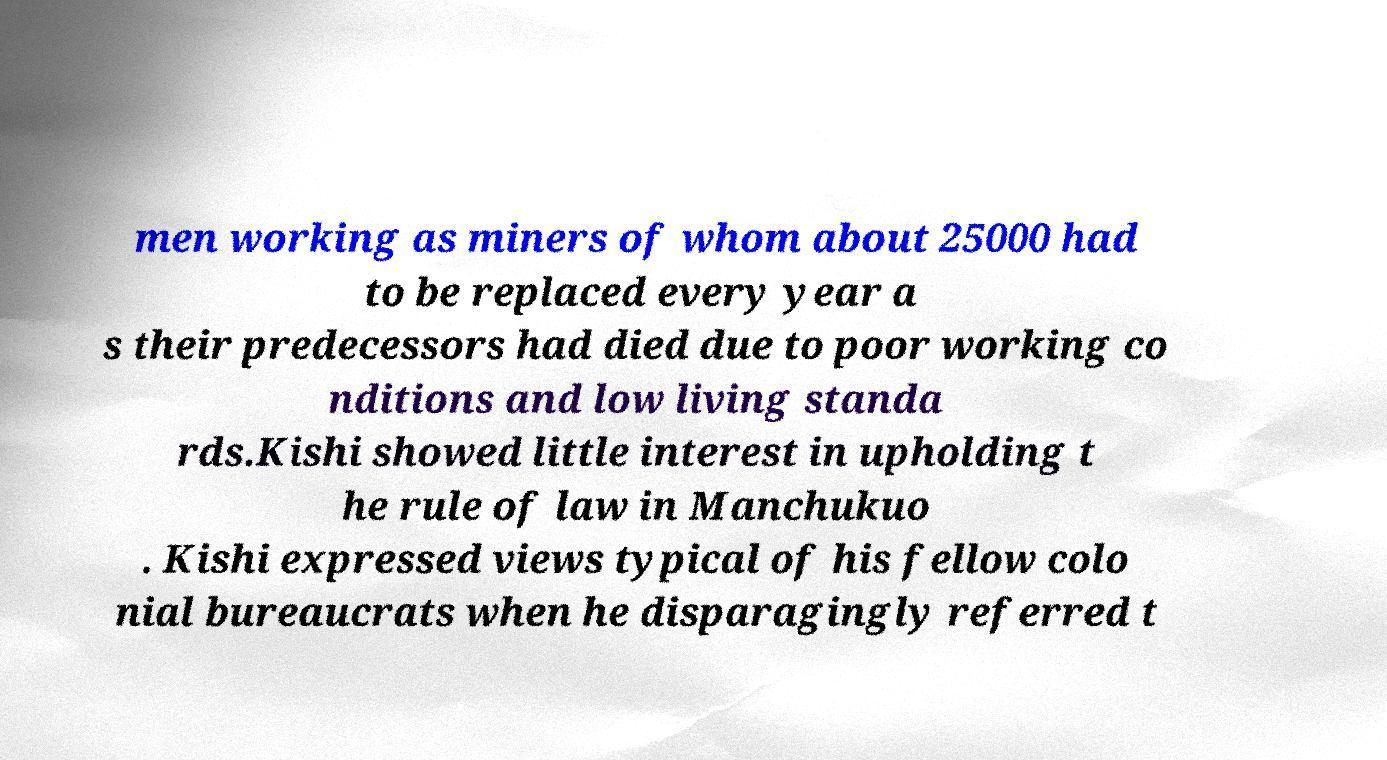Could you extract and type out the text from this image? men working as miners of whom about 25000 had to be replaced every year a s their predecessors had died due to poor working co nditions and low living standa rds.Kishi showed little interest in upholding t he rule of law in Manchukuo . Kishi expressed views typical of his fellow colo nial bureaucrats when he disparagingly referred t 